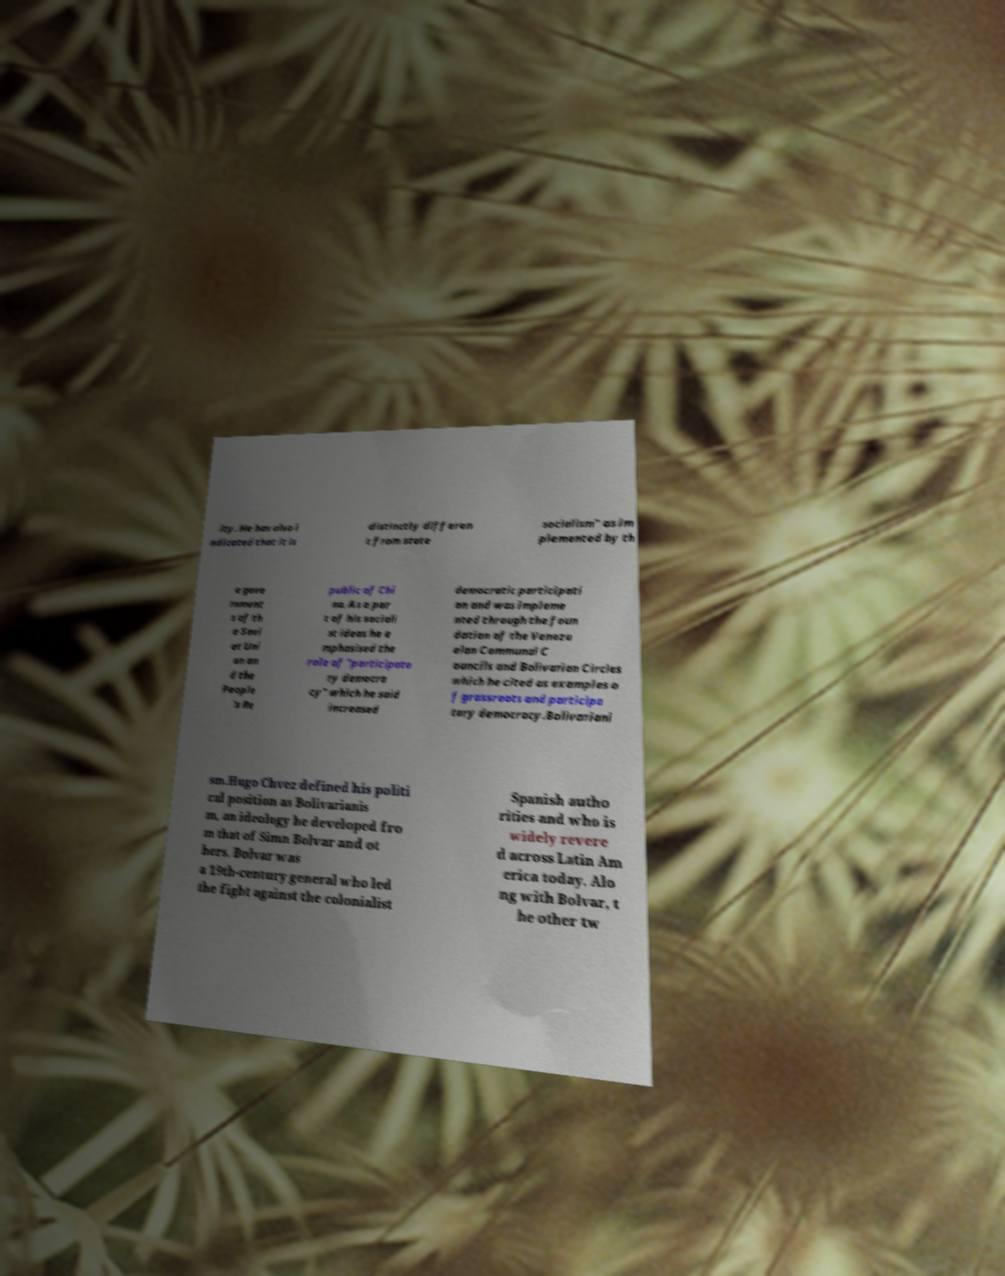There's text embedded in this image that I need extracted. Can you transcribe it verbatim? ity. He has also i ndicated that it is distinctly differen t from state socialism" as im plemented by th e gove rnment s of th e Sovi et Uni on an d the People 's Re public of Chi na. As a par t of his sociali st ideas he e mphasised the role of "participato ry democra cy" which he said increased democratic participati on and was impleme nted through the foun dation of the Venezu elan Communal C ouncils and Bolivarian Circles which he cited as examples o f grassroots and participa tory democracy.Bolivariani sm.Hugo Chvez defined his politi cal position as Bolivarianis m, an ideology he developed fro m that of Simn Bolvar and ot hers. Bolvar was a 19th-century general who led the fight against the colonialist Spanish autho rities and who is widely revere d across Latin Am erica today. Alo ng with Bolvar, t he other tw 